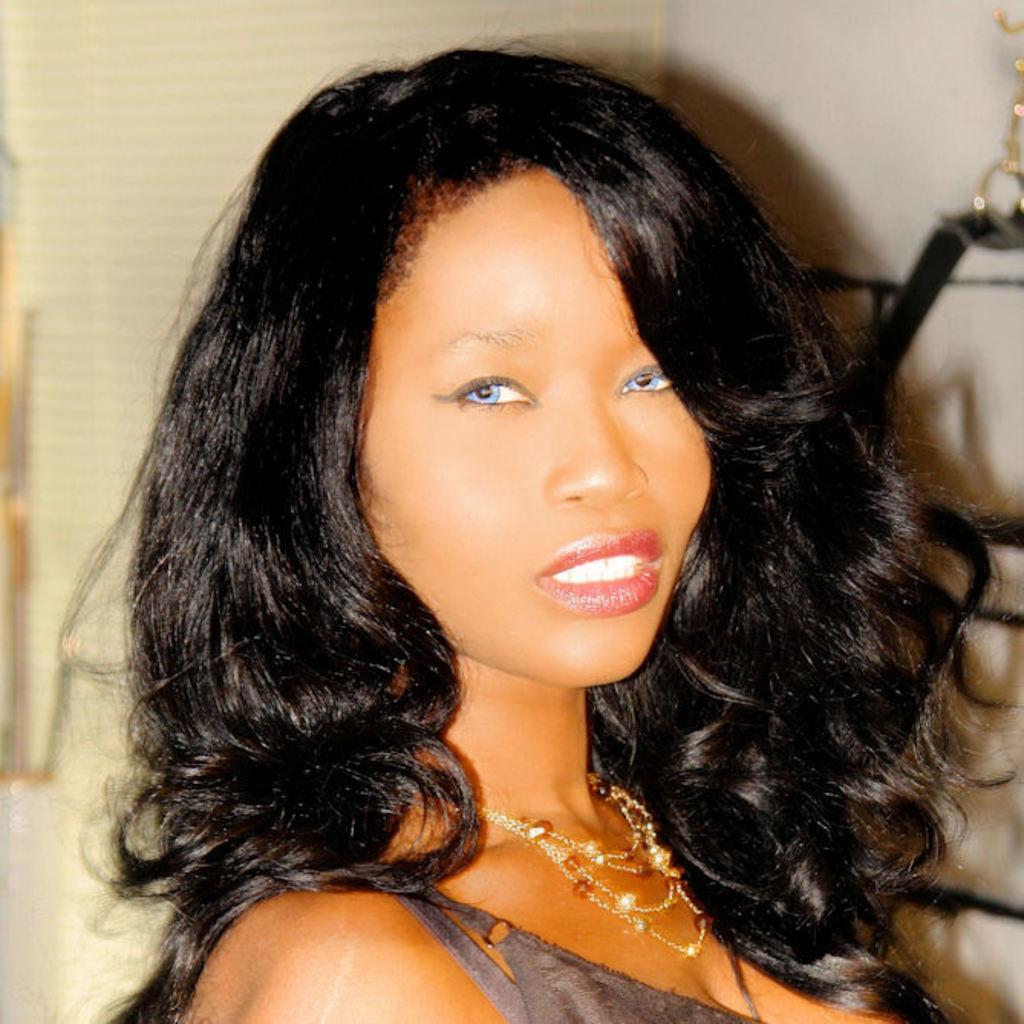In one or two sentences, can you explain what this image depicts? This picture describe about the women with black curly hair, smiling and giving a pose into the camera. 